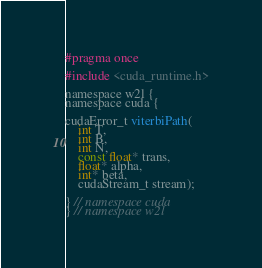<code> <loc_0><loc_0><loc_500><loc_500><_Cuda_>#pragma once

#include <cuda_runtime.h>

namespace w2l {
namespace cuda {

cudaError_t viterbiPath(
    int T,
    int B,
    int N,
    const float* trans,
    float* alpha,
    int* beta,
    cudaStream_t stream);

} // namespace cuda
} // namespace w2l
</code> 